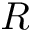<formula> <loc_0><loc_0><loc_500><loc_500>R</formula> 